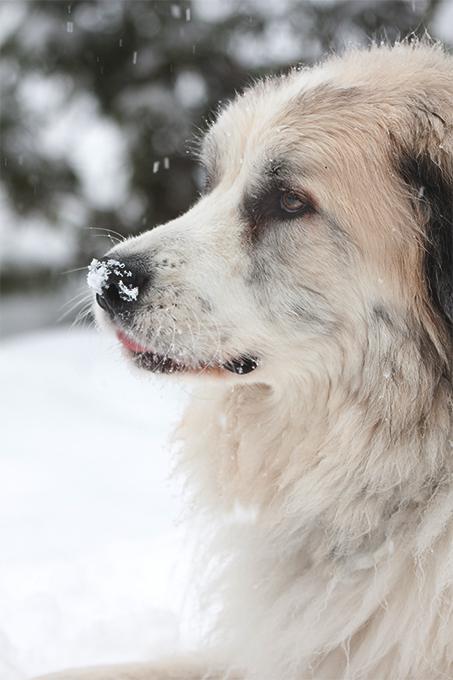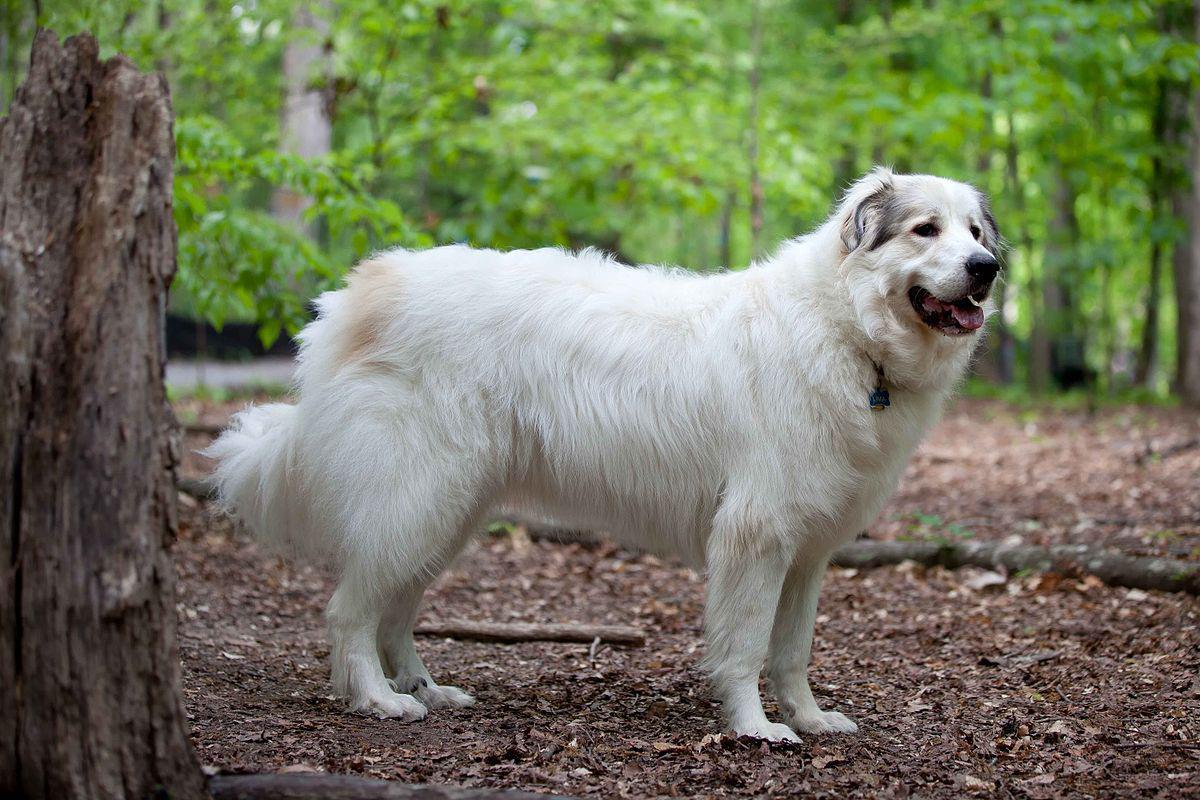The first image is the image on the left, the second image is the image on the right. Analyze the images presented: Is the assertion "One image shows a puppy on the grass." valid? Answer yes or no. No. 